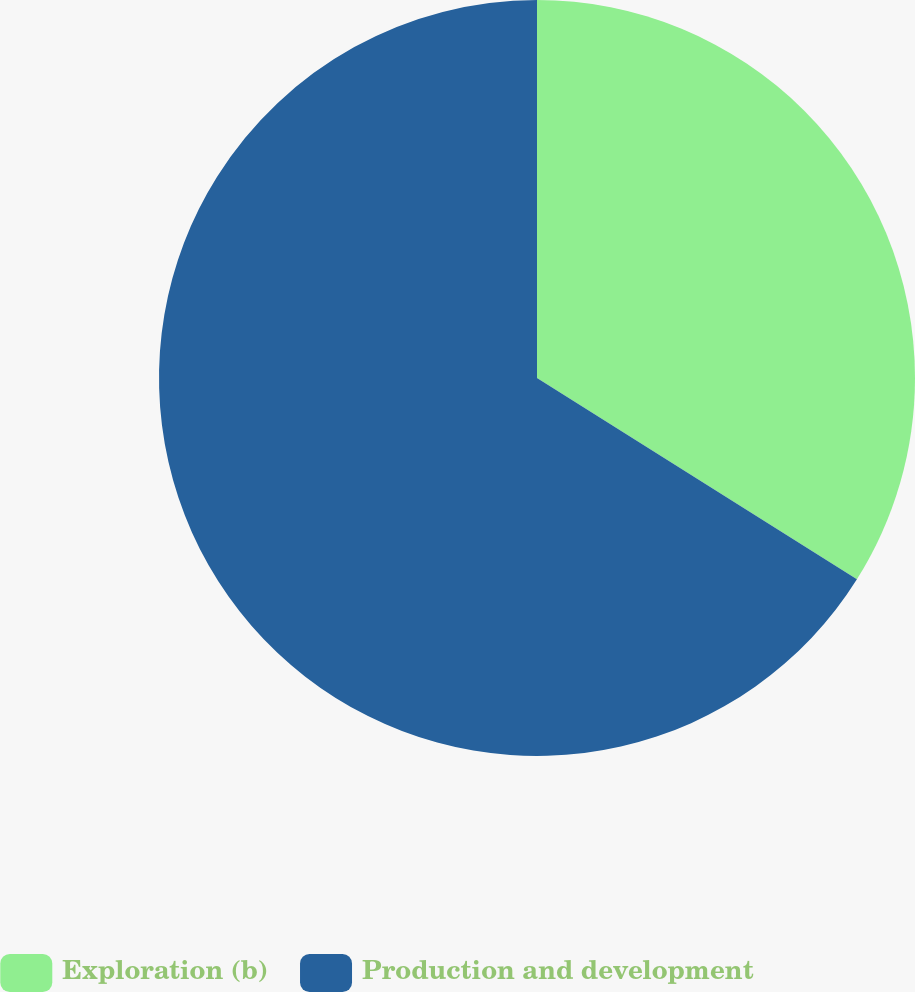Convert chart to OTSL. <chart><loc_0><loc_0><loc_500><loc_500><pie_chart><fcel>Exploration (b)<fcel>Production and development<nl><fcel>33.94%<fcel>66.06%<nl></chart> 